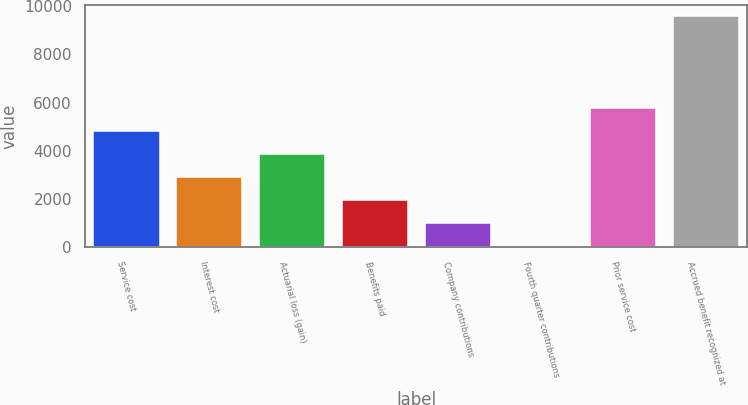Convert chart to OTSL. <chart><loc_0><loc_0><loc_500><loc_500><bar_chart><fcel>Service cost<fcel>Interest cost<fcel>Actuarial loss (gain)<fcel>Benefits paid<fcel>Company contributions<fcel>Fourth quarter contributions<fcel>Prior service cost<fcel>Accrued benefit recognized at<nl><fcel>4809<fcel>2900.2<fcel>3854.6<fcel>1945.8<fcel>991.4<fcel>37<fcel>5763.4<fcel>9581<nl></chart> 